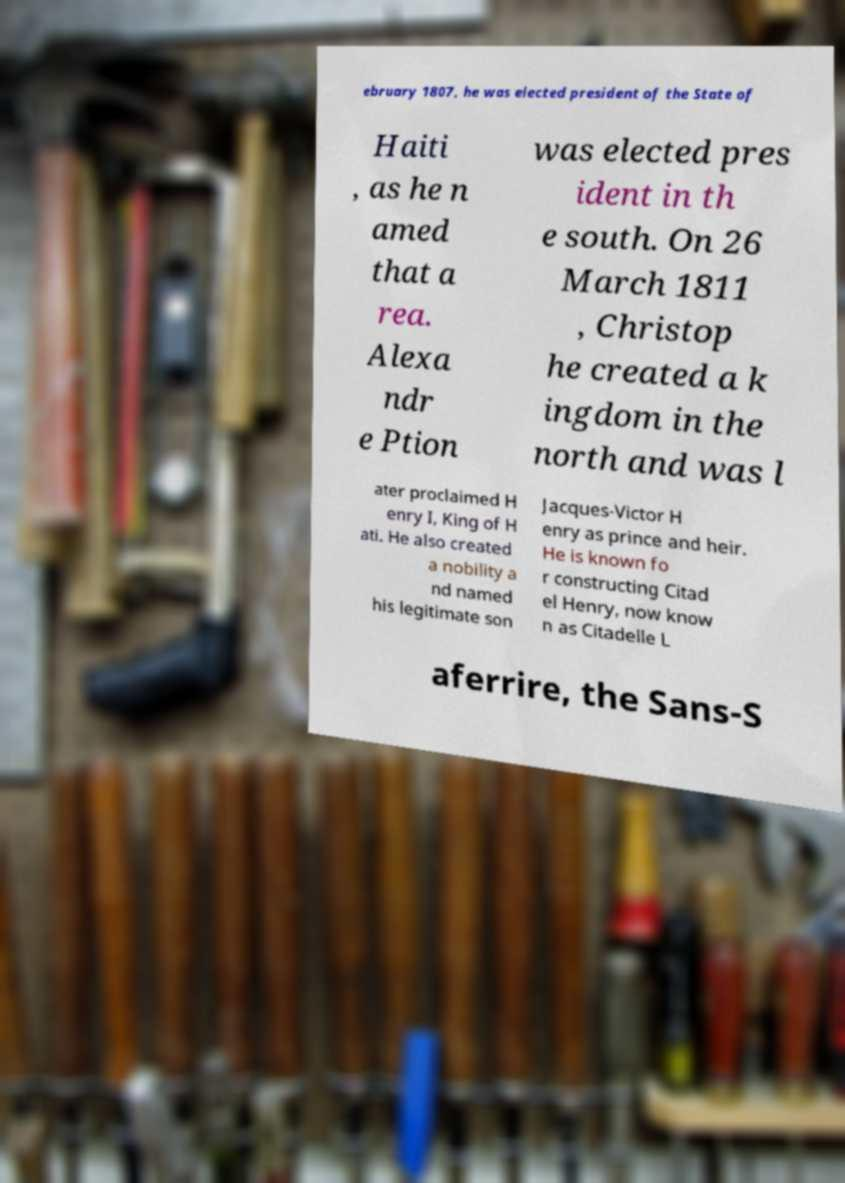For documentation purposes, I need the text within this image transcribed. Could you provide that? ebruary 1807, he was elected president of the State of Haiti , as he n amed that a rea. Alexa ndr e Ption was elected pres ident in th e south. On 26 March 1811 , Christop he created a k ingdom in the north and was l ater proclaimed H enry I, King of H ati. He also created a nobility a nd named his legitimate son Jacques-Victor H enry as prince and heir. He is known fo r constructing Citad el Henry, now know n as Citadelle L aferrire, the Sans-S 